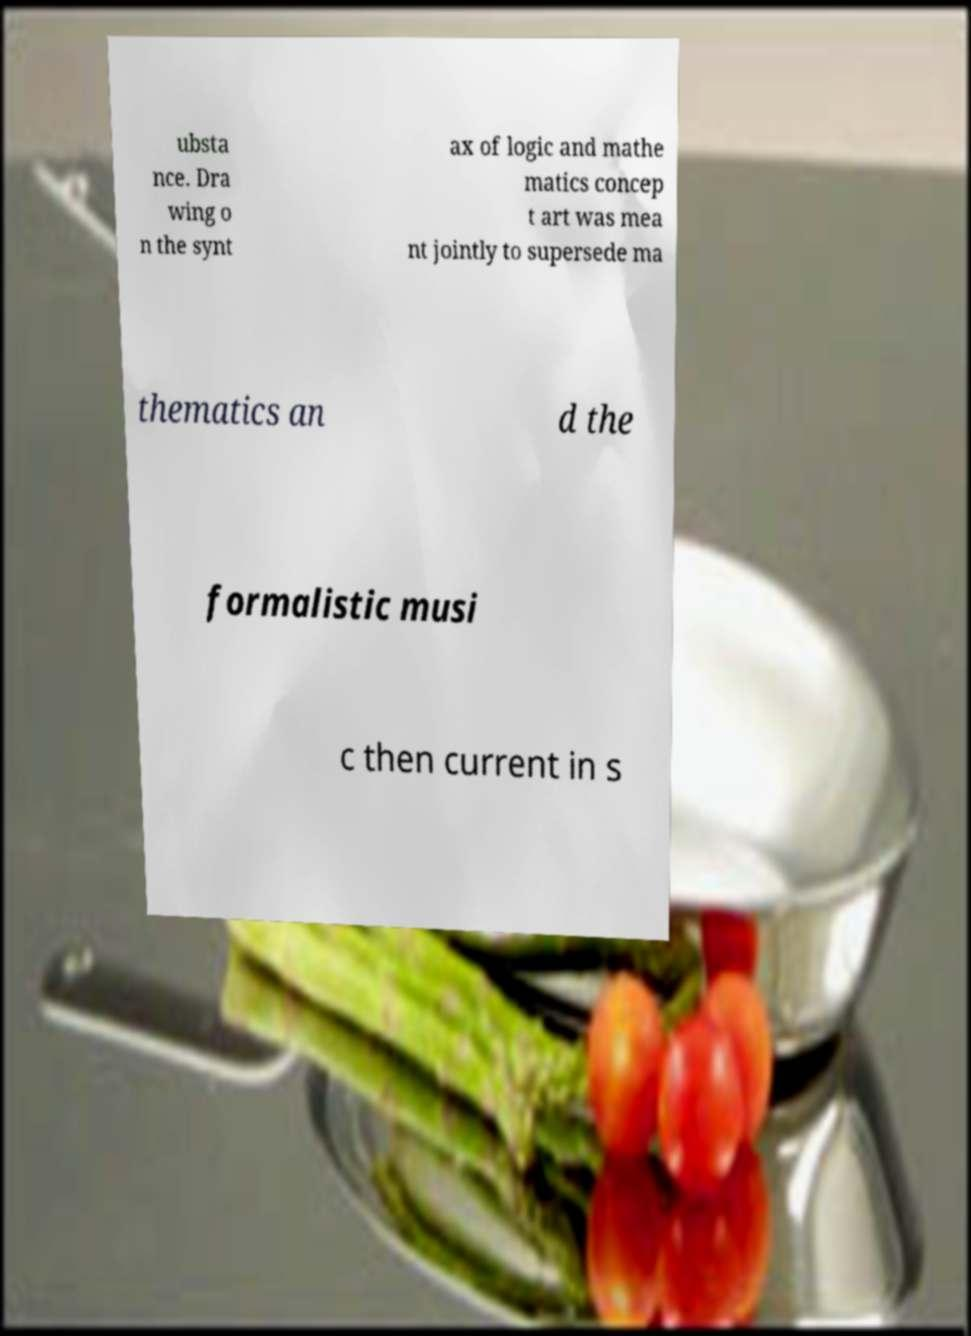Please identify and transcribe the text found in this image. ubsta nce. Dra wing o n the synt ax of logic and mathe matics concep t art was mea nt jointly to supersede ma thematics an d the formalistic musi c then current in s 